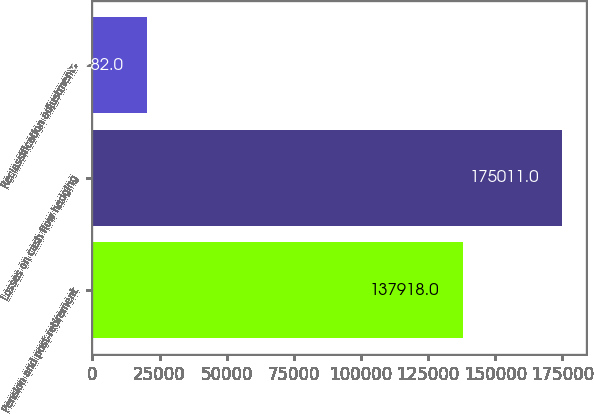Convert chart to OTSL. <chart><loc_0><loc_0><loc_500><loc_500><bar_chart><fcel>Pension and post-retirement<fcel>Losses on cash flow hedging<fcel>Reclassification adjustments<nl><fcel>137918<fcel>175011<fcel>20282<nl></chart> 